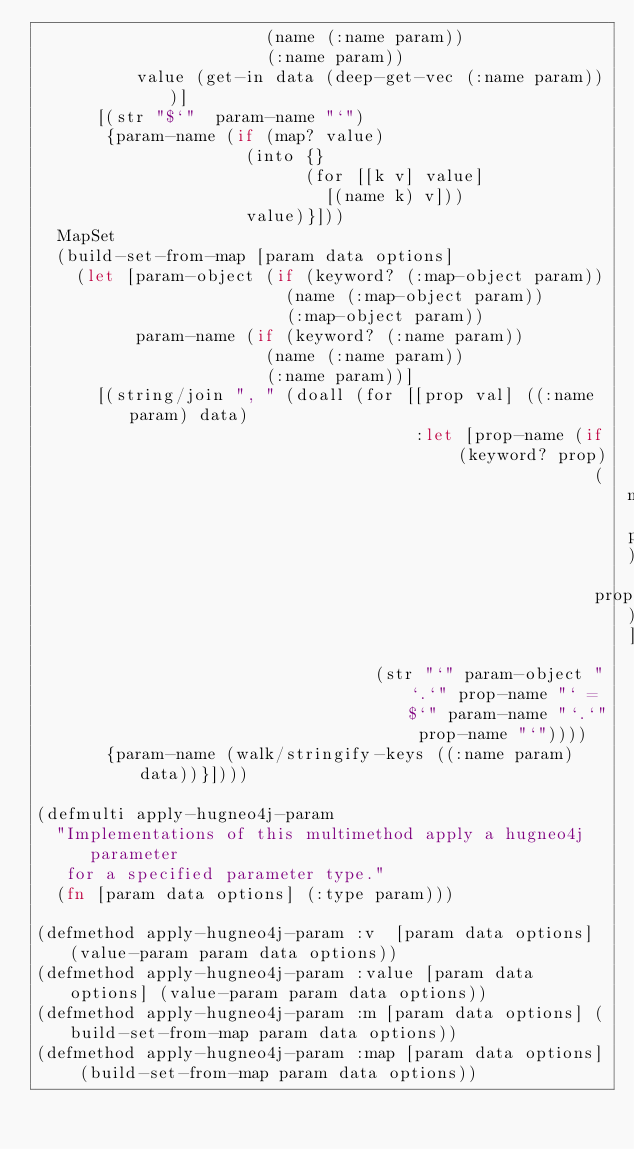Convert code to text. <code><loc_0><loc_0><loc_500><loc_500><_Clojure_>                       (name (:name param))
                       (:name param))
          value (get-in data (deep-get-vec (:name param)))]
      [(str "$`"  param-name "`")
       {param-name (if (map? value)
                     (into {}
                           (for [[k v] value]
                             [(name k) v]))
                     value)}]))
  MapSet
  (build-set-from-map [param data options]
    (let [param-object (if (keyword? (:map-object param))
                         (name (:map-object param))
                         (:map-object param))
          param-name (if (keyword? (:name param))
                       (name (:name param))
                       (:name param))]
      [(string/join ", " (doall (for [[prop val] ((:name param) data)
                                      :let [prop-name (if (keyword? prop)
                                                        (name prop)
                                                        prop)]]
                                  (str "`" param-object "`.`" prop-name "` = $`" param-name "`.`" prop-name "`"))))
       {param-name (walk/stringify-keys ((:name param) data))}])))

(defmulti apply-hugneo4j-param
  "Implementations of this multimethod apply a hugneo4j parameter
   for a specified parameter type."
  (fn [param data options] (:type param)))

(defmethod apply-hugneo4j-param :v  [param data options] (value-param param data options))
(defmethod apply-hugneo4j-param :value [param data options] (value-param param data options))
(defmethod apply-hugneo4j-param :m [param data options] (build-set-from-map param data options))
(defmethod apply-hugneo4j-param :map [param data options] (build-set-from-map param data options))
</code> 